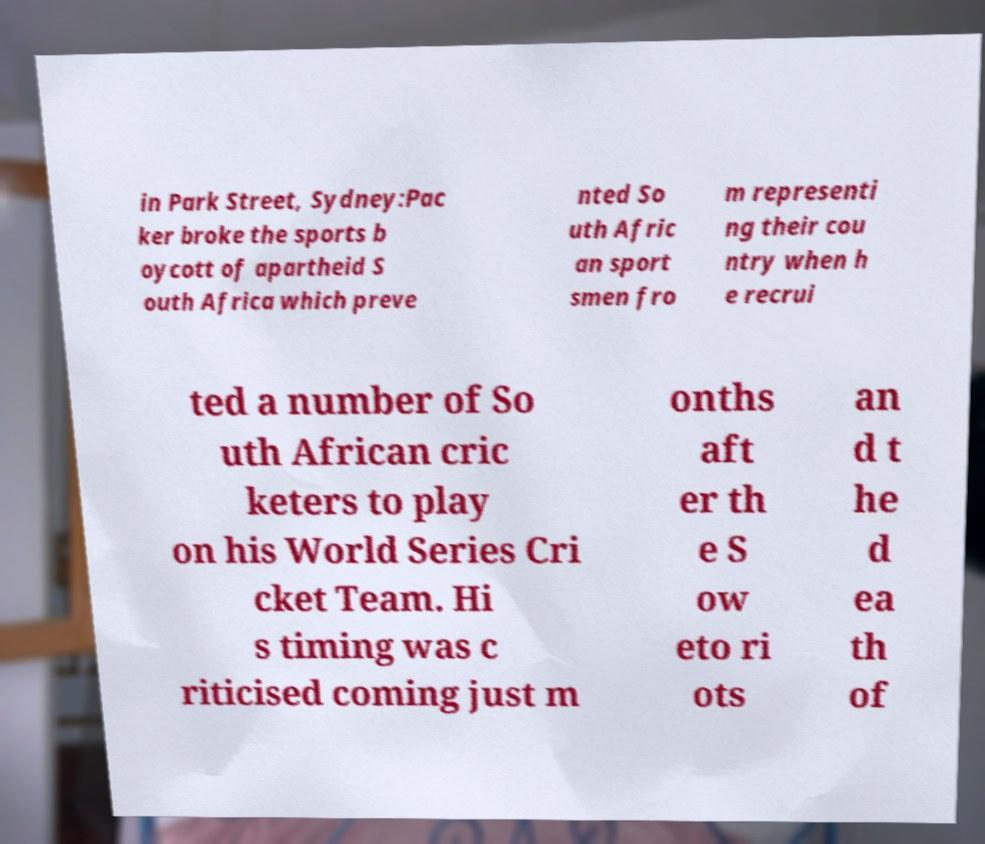Please read and relay the text visible in this image. What does it say? in Park Street, Sydney:Pac ker broke the sports b oycott of apartheid S outh Africa which preve nted So uth Afric an sport smen fro m representi ng their cou ntry when h e recrui ted a number of So uth African cric keters to play on his World Series Cri cket Team. Hi s timing was c riticised coming just m onths aft er th e S ow eto ri ots an d t he d ea th of 